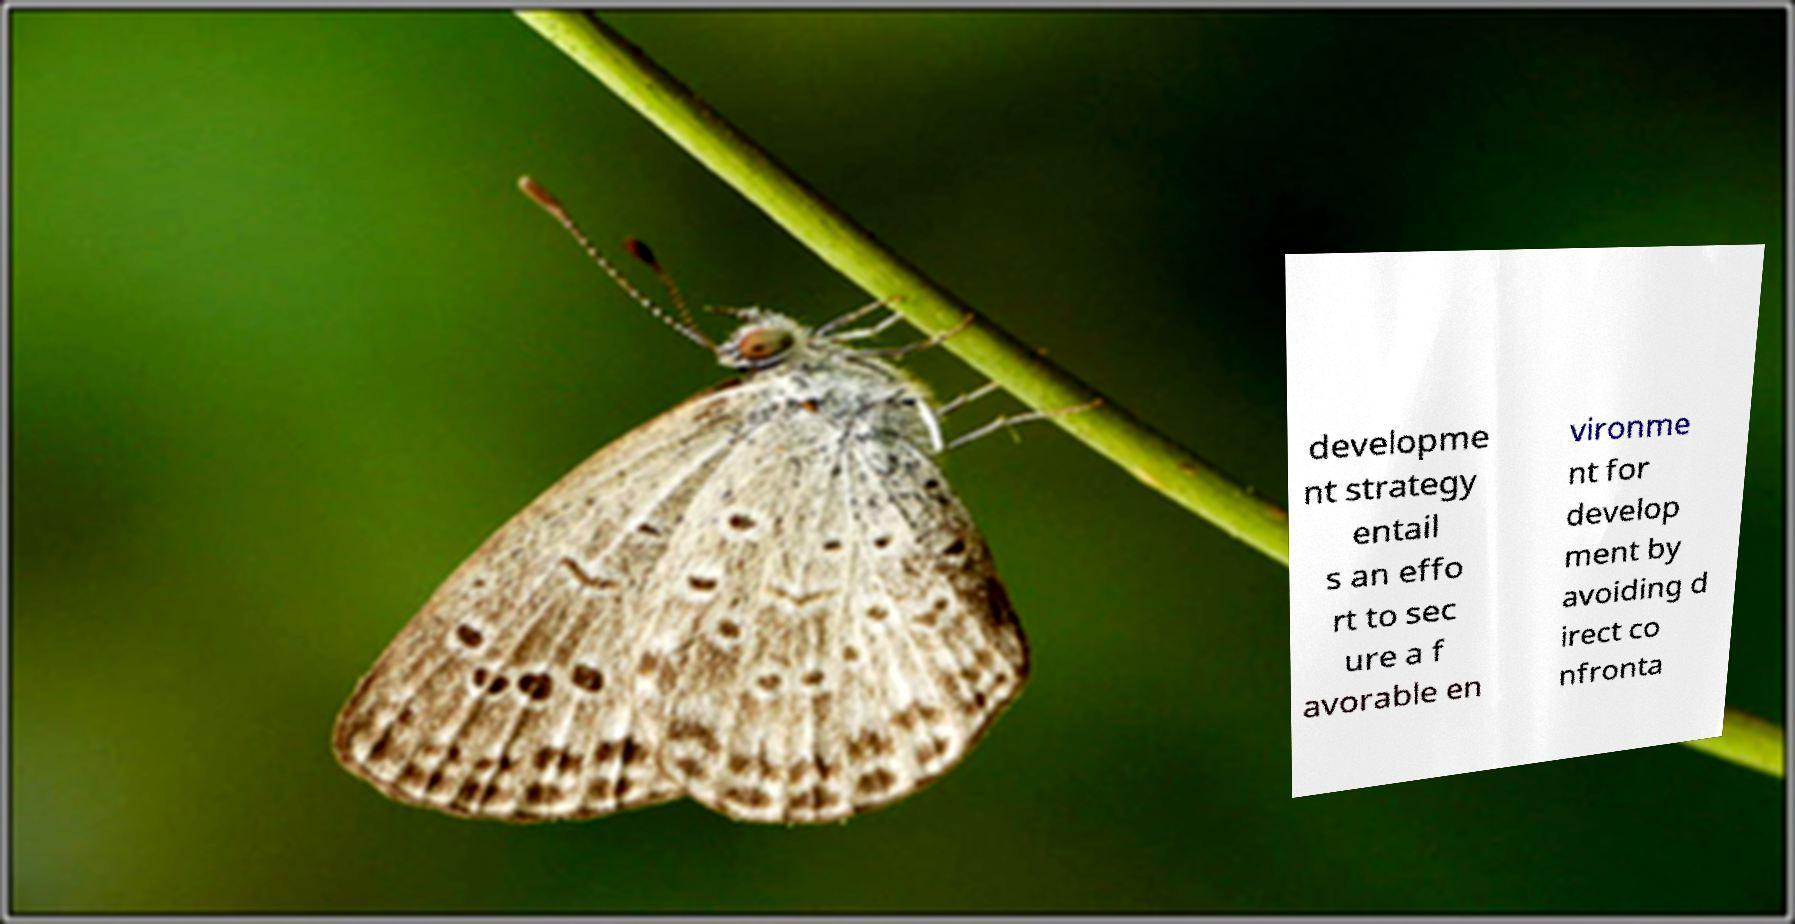There's text embedded in this image that I need extracted. Can you transcribe it verbatim? developme nt strategy entail s an effo rt to sec ure a f avorable en vironme nt for develop ment by avoiding d irect co nfronta 